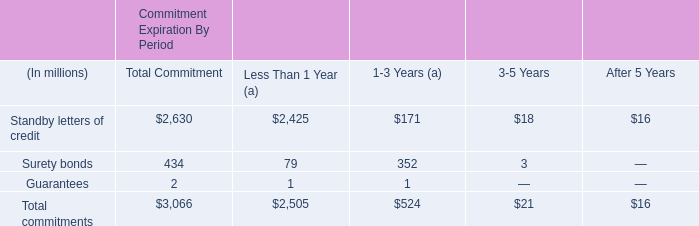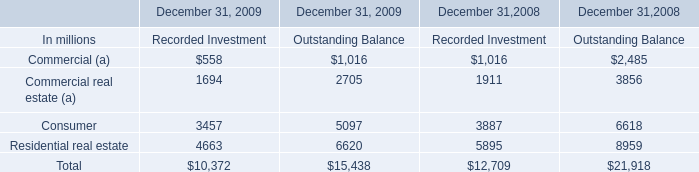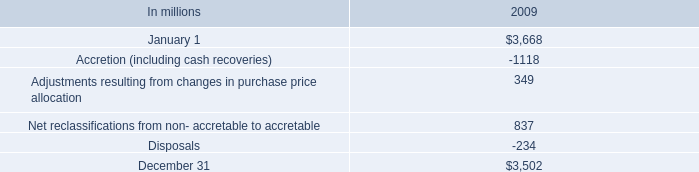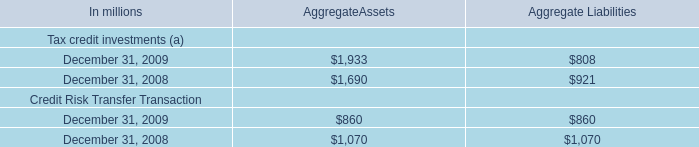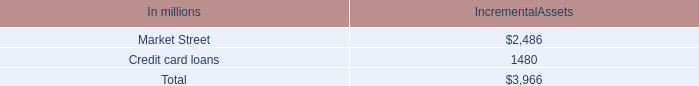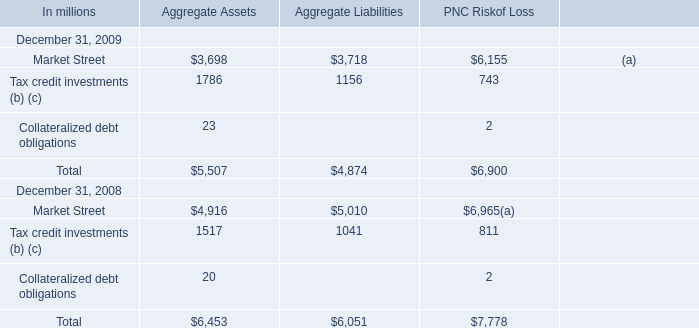Is the total amount of all elements in 2009 greater than that in 2008 for aggregate liabilities? 
Answer: No. 